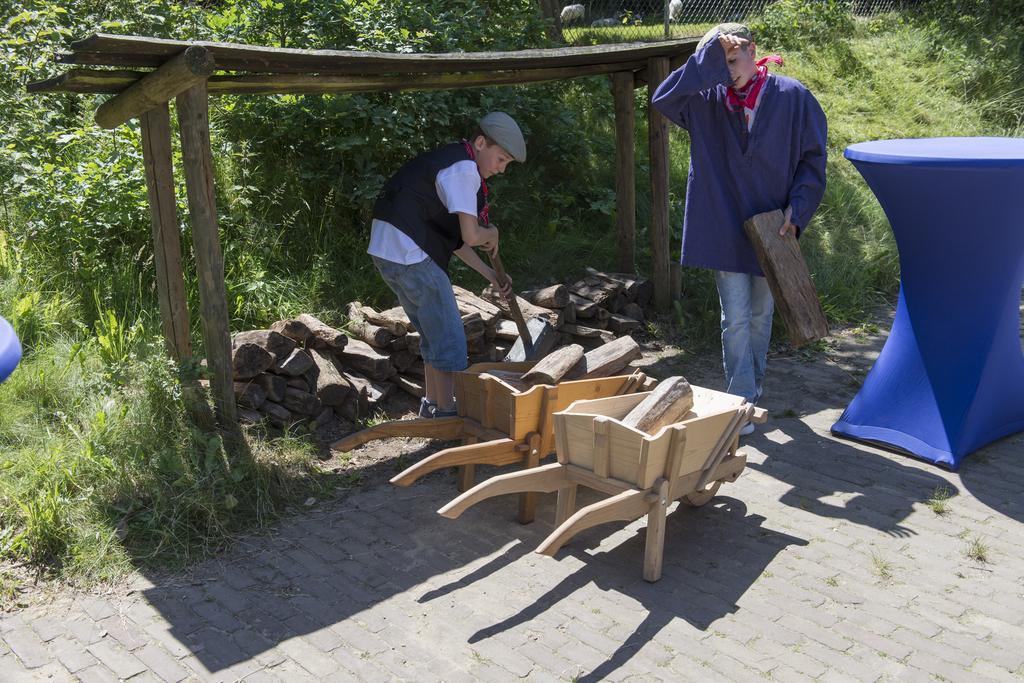Describe this image in one or two sentences. Boy in white t-shirt and black coat is holding a long wooden stick in his hand and beside him, we see two wooden trolleys. Beside that, we see a man in a blue coat is holding a wooden stick in his hand and beside that, we see a blue color table like and behind him, we see wooden bench. There are many trees and a fence in the background. We even see grass. 